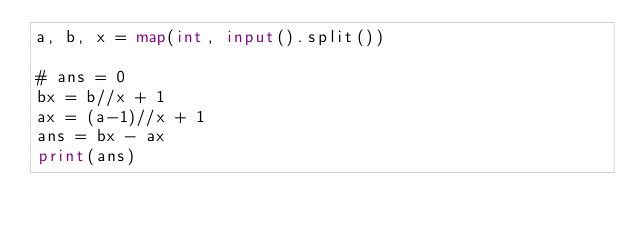<code> <loc_0><loc_0><loc_500><loc_500><_Python_>a, b, x = map(int, input().split())

# ans = 0
bx = b//x + 1
ax = (a-1)//x + 1
ans = bx - ax
print(ans)</code> 